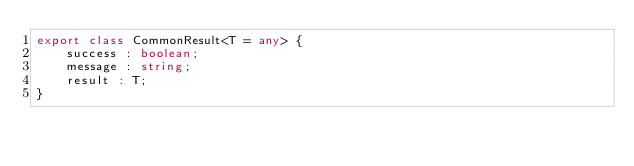<code> <loc_0><loc_0><loc_500><loc_500><_TypeScript_>export class CommonResult<T = any> {
    success : boolean;
    message : string;
    result : T;
}</code> 